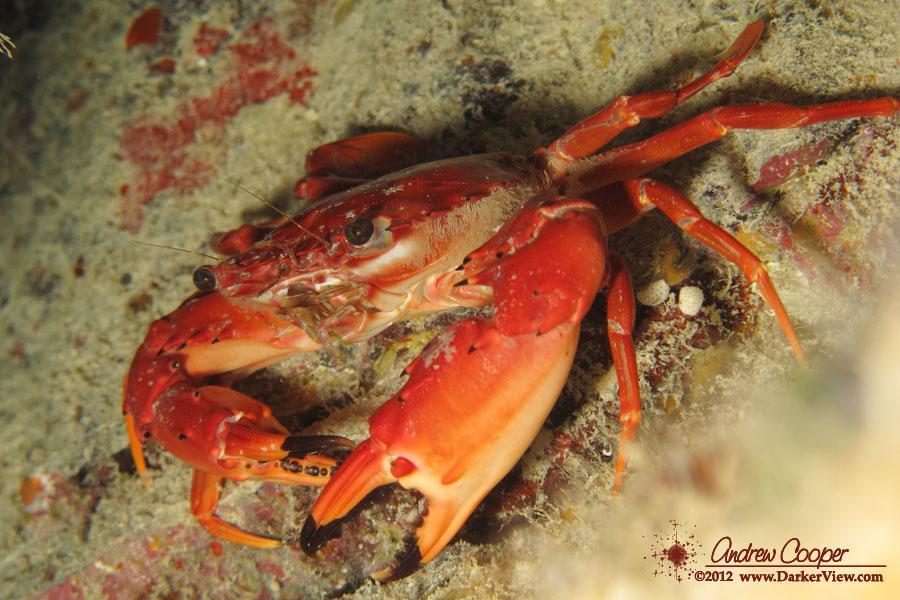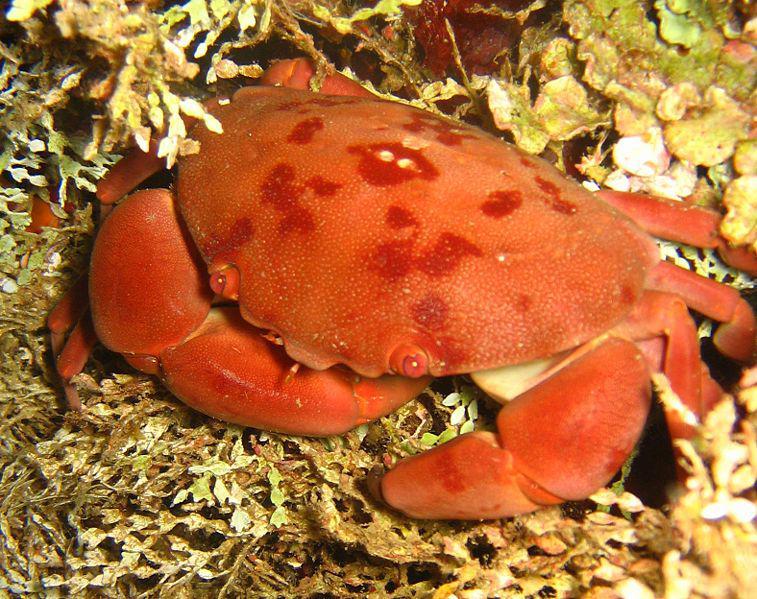The first image is the image on the left, the second image is the image on the right. Given the left and right images, does the statement "All of the crabs have their front limbs extended and their claws open wide." hold true? Answer yes or no. No. 